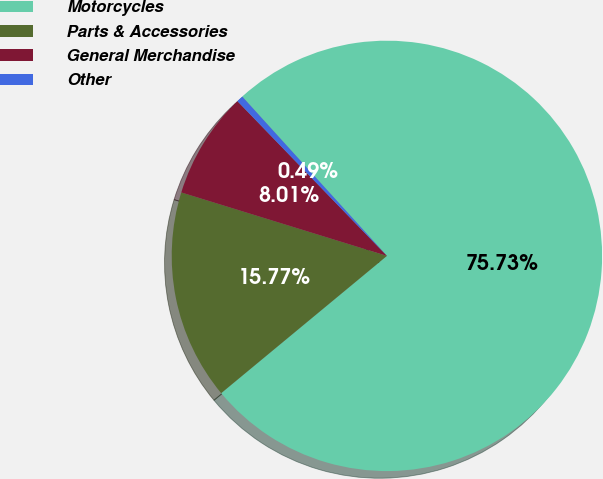<chart> <loc_0><loc_0><loc_500><loc_500><pie_chart><fcel>Motorcycles<fcel>Parts & Accessories<fcel>General Merchandise<fcel>Other<nl><fcel>75.73%<fcel>15.77%<fcel>8.01%<fcel>0.49%<nl></chart> 